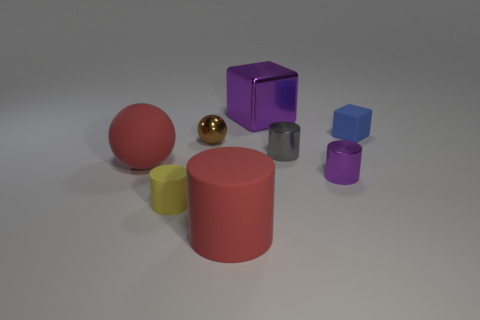There is a small cube that is made of the same material as the large cylinder; what color is it?
Keep it short and to the point. Blue. Does the big rubber cylinder have the same color as the big matte ball?
Give a very brief answer. Yes. There is a blue rubber object that is the same size as the brown metallic ball; what is its shape?
Your response must be concise. Cube. What is the size of the metallic cube?
Make the answer very short. Large. Does the ball in front of the tiny metal ball have the same size as the purple thing in front of the purple cube?
Give a very brief answer. No. The block behind the matte cube right of the small shiny sphere is what color?
Your response must be concise. Purple. What material is the gray object that is the same size as the brown metallic sphere?
Ensure brevity in your answer.  Metal. How many metal objects are gray things or red spheres?
Provide a short and direct response. 1. What is the color of the rubber object that is right of the yellow matte object and in front of the small purple shiny object?
Make the answer very short. Red. How many blocks are on the left side of the small blue rubber cube?
Offer a terse response. 1. 